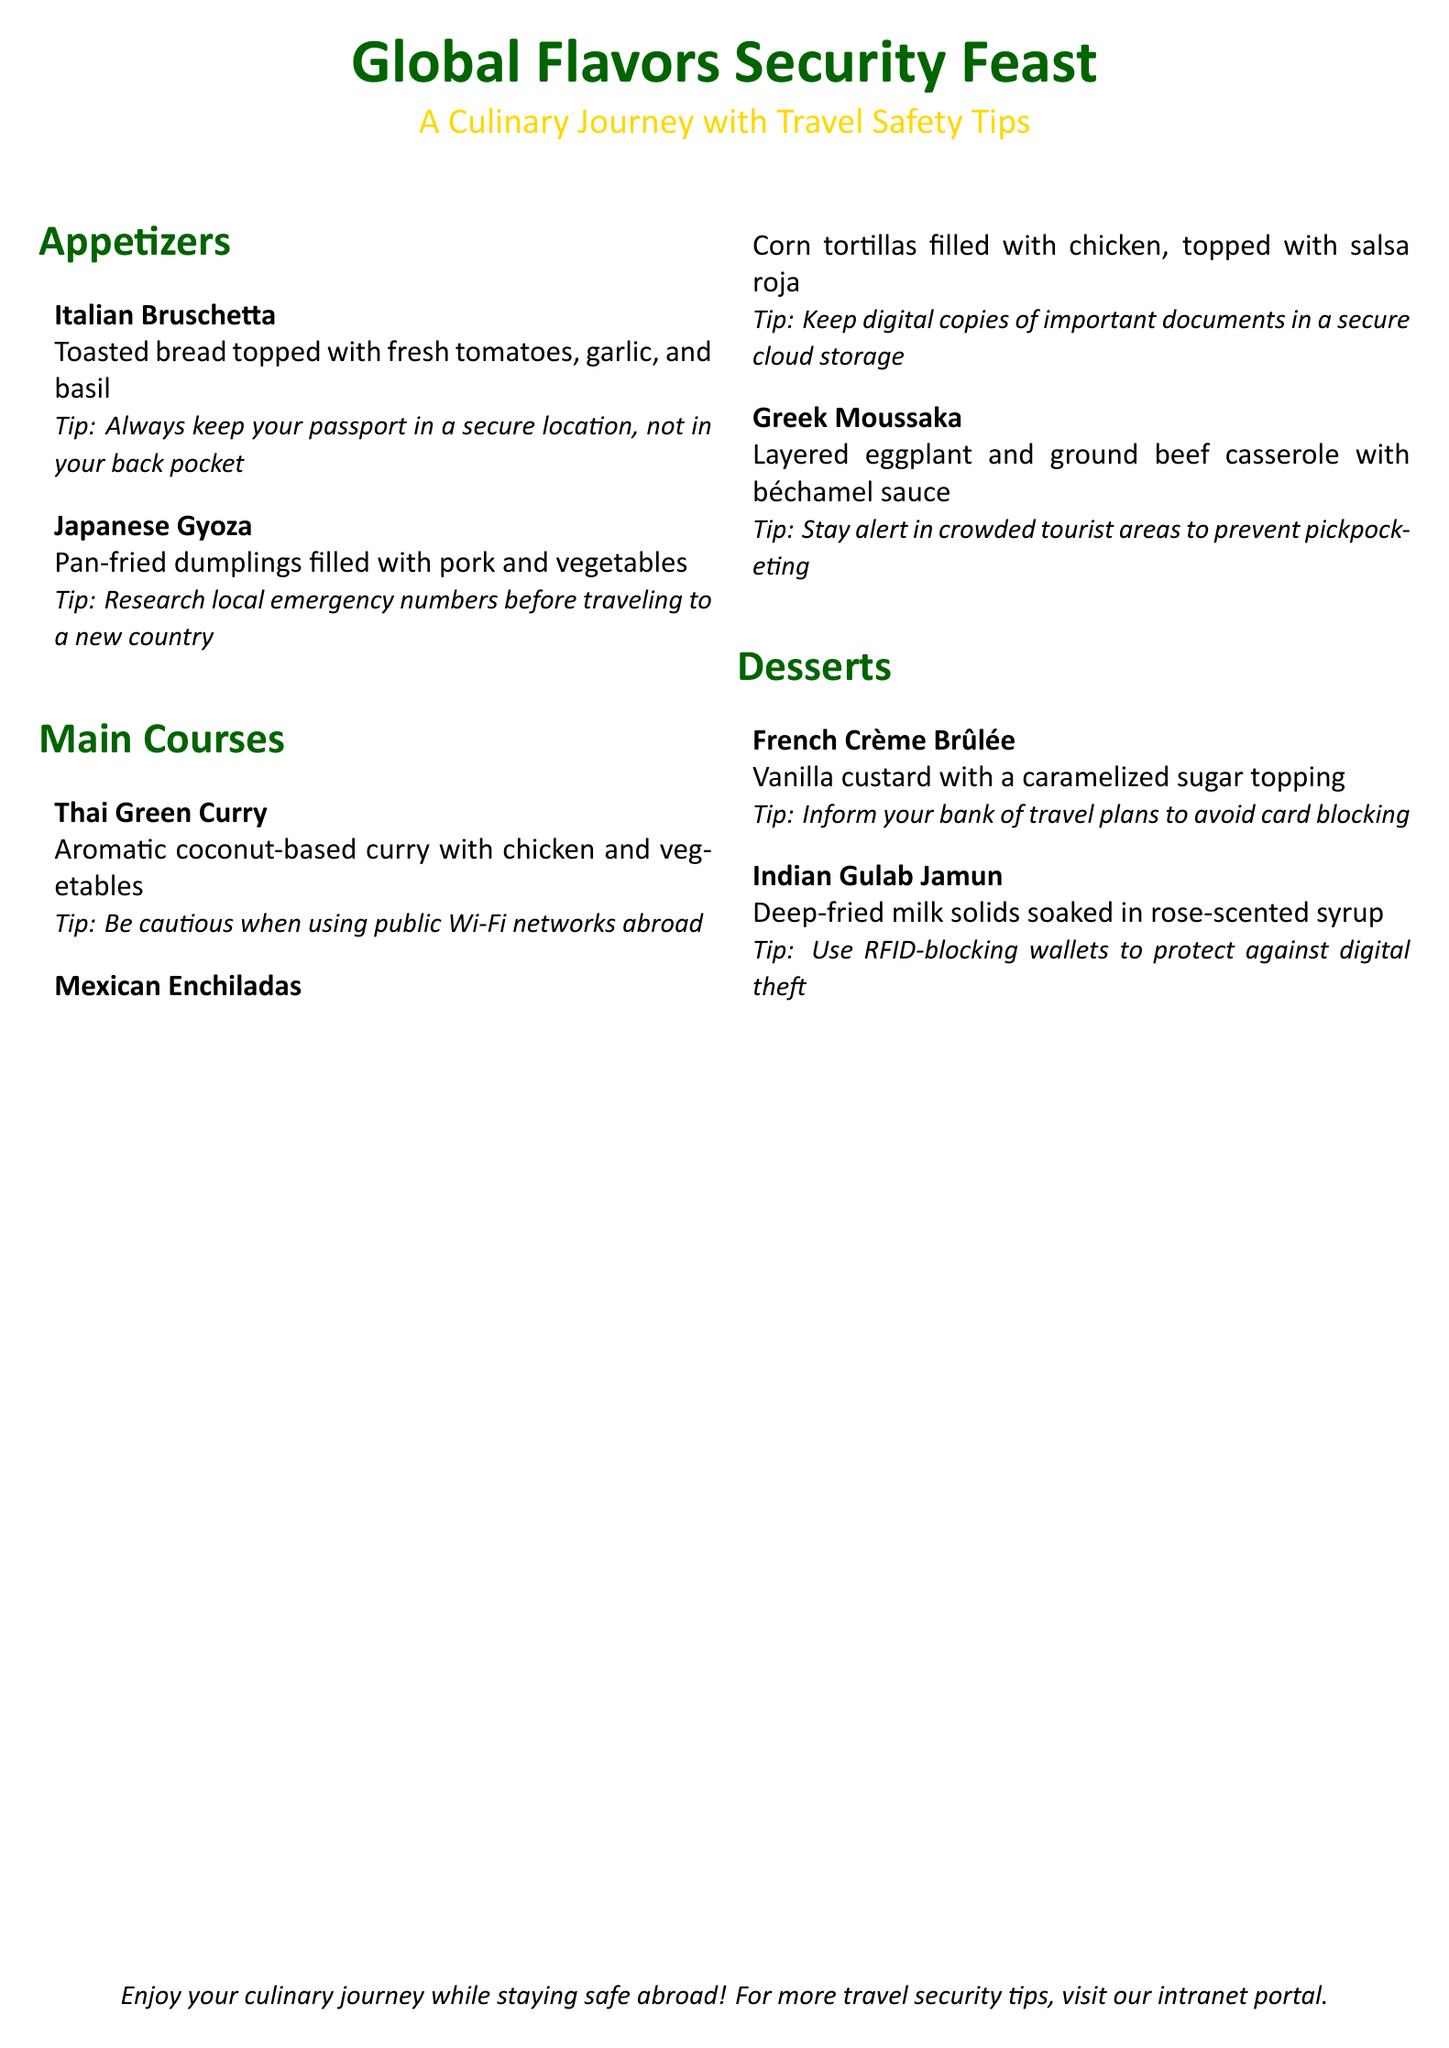What is the title of the document? The title is the main heading of the document, which highlights the theme of the culinary offerings.
Answer: Global Flavors Security Feast What cuisine does the Bruschetta belong to? The Bruschetta is categorized under the appetizers section, representing Italian cuisine.
Answer: Italian How many desserts are listed in the menu? The menu lists an itemized section for desserts, counting them will yield the answer.
Answer: 2 What is the main ingredient in Japanese Gyoza? The Gyoza's description specifies its filling, providing the necessary detail to answer the question.
Answer: Pork What travel safety tip is associated with French Crème Brûlée? The tip is directly linked to the dessert entry in the menu, providing specific advice.
Answer: Inform your bank of travel plans to avoid card blocking Which dish features a coconut-based curry? The description of the main courses provides a clue to identify this specific dish within the menu.
Answer: Thai Green Curry What is the topping for Indian Gulab Jamun? The dessert description gives details about the syrup that enhances the dish's flavor.
Answer: Rose-scented syrup Which country is associated with the dish Enchiladas? The dish name is directly related to a specific country, which can be confirmed by its listing in the menu.
Answer: Mexico What document structure is used in this menu? The structure includes sections like appetizers, main courses, and desserts, highlighting the format used for the menu.
Answer: Sections 